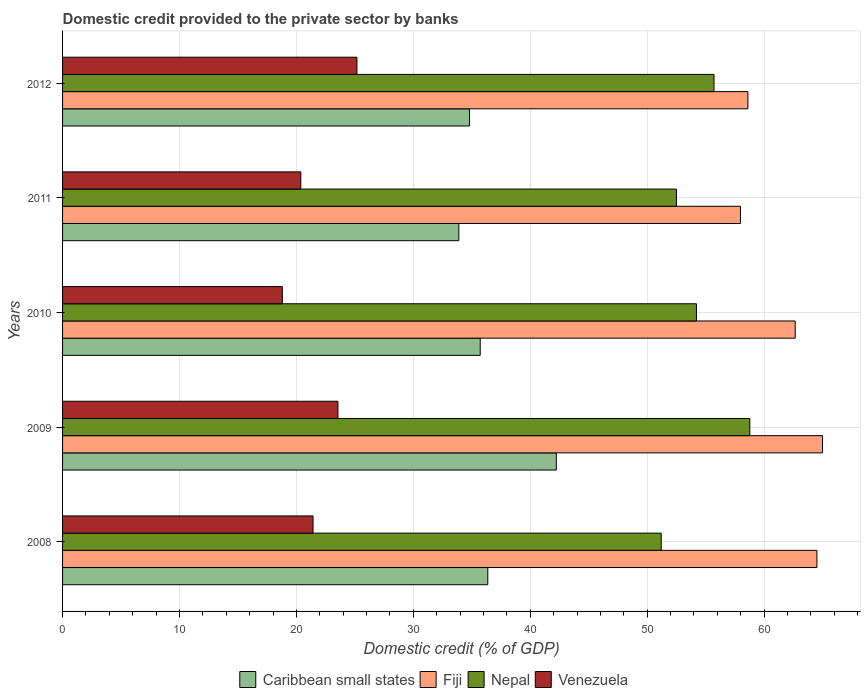How many different coloured bars are there?
Provide a succinct answer. 4. Are the number of bars per tick equal to the number of legend labels?
Your response must be concise. Yes. Are the number of bars on each tick of the Y-axis equal?
Give a very brief answer. Yes. How many bars are there on the 2nd tick from the top?
Offer a terse response. 4. How many bars are there on the 1st tick from the bottom?
Provide a short and direct response. 4. What is the domestic credit provided to the private sector by banks in Nepal in 2011?
Keep it short and to the point. 52.5. Across all years, what is the maximum domestic credit provided to the private sector by banks in Nepal?
Your response must be concise. 58.77. Across all years, what is the minimum domestic credit provided to the private sector by banks in Venezuela?
Keep it short and to the point. 18.8. In which year was the domestic credit provided to the private sector by banks in Nepal maximum?
Your answer should be compact. 2009. In which year was the domestic credit provided to the private sector by banks in Venezuela minimum?
Offer a very short reply. 2010. What is the total domestic credit provided to the private sector by banks in Venezuela in the graph?
Offer a terse response. 109.32. What is the difference between the domestic credit provided to the private sector by banks in Venezuela in 2009 and that in 2010?
Keep it short and to the point. 4.75. What is the difference between the domestic credit provided to the private sector by banks in Caribbean small states in 2008 and the domestic credit provided to the private sector by banks in Venezuela in 2012?
Keep it short and to the point. 11.19. What is the average domestic credit provided to the private sector by banks in Nepal per year?
Give a very brief answer. 54.48. In the year 2011, what is the difference between the domestic credit provided to the private sector by banks in Fiji and domestic credit provided to the private sector by banks in Venezuela?
Ensure brevity in your answer.  37.6. What is the ratio of the domestic credit provided to the private sector by banks in Fiji in 2010 to that in 2012?
Provide a short and direct response. 1.07. Is the domestic credit provided to the private sector by banks in Venezuela in 2011 less than that in 2012?
Your response must be concise. Yes. Is the difference between the domestic credit provided to the private sector by banks in Fiji in 2009 and 2010 greater than the difference between the domestic credit provided to the private sector by banks in Venezuela in 2009 and 2010?
Offer a terse response. No. What is the difference between the highest and the second highest domestic credit provided to the private sector by banks in Nepal?
Keep it short and to the point. 3.06. What is the difference between the highest and the lowest domestic credit provided to the private sector by banks in Nepal?
Offer a very short reply. 7.58. Is the sum of the domestic credit provided to the private sector by banks in Venezuela in 2008 and 2009 greater than the maximum domestic credit provided to the private sector by banks in Caribbean small states across all years?
Your response must be concise. Yes. What does the 4th bar from the top in 2012 represents?
Your response must be concise. Caribbean small states. What does the 4th bar from the bottom in 2011 represents?
Provide a succinct answer. Venezuela. How many bars are there?
Provide a succinct answer. 20. Are all the bars in the graph horizontal?
Ensure brevity in your answer.  Yes. How many years are there in the graph?
Keep it short and to the point. 5. Does the graph contain grids?
Provide a short and direct response. Yes. Where does the legend appear in the graph?
Your answer should be very brief. Bottom center. What is the title of the graph?
Give a very brief answer. Domestic credit provided to the private sector by banks. What is the label or title of the X-axis?
Provide a short and direct response. Domestic credit (% of GDP). What is the label or title of the Y-axis?
Give a very brief answer. Years. What is the Domestic credit (% of GDP) in Caribbean small states in 2008?
Make the answer very short. 36.37. What is the Domestic credit (% of GDP) of Fiji in 2008?
Offer a terse response. 64.51. What is the Domestic credit (% of GDP) in Nepal in 2008?
Your answer should be compact. 51.2. What is the Domestic credit (% of GDP) of Venezuela in 2008?
Your response must be concise. 21.42. What is the Domestic credit (% of GDP) in Caribbean small states in 2009?
Keep it short and to the point. 42.23. What is the Domestic credit (% of GDP) in Fiji in 2009?
Your answer should be very brief. 64.99. What is the Domestic credit (% of GDP) of Nepal in 2009?
Your response must be concise. 58.77. What is the Domestic credit (% of GDP) in Venezuela in 2009?
Provide a short and direct response. 23.55. What is the Domestic credit (% of GDP) in Caribbean small states in 2010?
Give a very brief answer. 35.72. What is the Domestic credit (% of GDP) in Fiji in 2010?
Make the answer very short. 62.66. What is the Domestic credit (% of GDP) of Nepal in 2010?
Provide a short and direct response. 54.21. What is the Domestic credit (% of GDP) in Venezuela in 2010?
Your answer should be very brief. 18.8. What is the Domestic credit (% of GDP) of Caribbean small states in 2011?
Your answer should be compact. 33.89. What is the Domestic credit (% of GDP) in Fiji in 2011?
Your answer should be very brief. 57.97. What is the Domestic credit (% of GDP) in Nepal in 2011?
Make the answer very short. 52.5. What is the Domestic credit (% of GDP) in Venezuela in 2011?
Provide a short and direct response. 20.37. What is the Domestic credit (% of GDP) of Caribbean small states in 2012?
Offer a very short reply. 34.81. What is the Domestic credit (% of GDP) of Fiji in 2012?
Your answer should be compact. 58.61. What is the Domestic credit (% of GDP) in Nepal in 2012?
Give a very brief answer. 55.71. What is the Domestic credit (% of GDP) of Venezuela in 2012?
Make the answer very short. 25.18. Across all years, what is the maximum Domestic credit (% of GDP) of Caribbean small states?
Offer a very short reply. 42.23. Across all years, what is the maximum Domestic credit (% of GDP) in Fiji?
Give a very brief answer. 64.99. Across all years, what is the maximum Domestic credit (% of GDP) in Nepal?
Offer a terse response. 58.77. Across all years, what is the maximum Domestic credit (% of GDP) in Venezuela?
Keep it short and to the point. 25.18. Across all years, what is the minimum Domestic credit (% of GDP) of Caribbean small states?
Offer a terse response. 33.89. Across all years, what is the minimum Domestic credit (% of GDP) in Fiji?
Provide a succinct answer. 57.97. Across all years, what is the minimum Domestic credit (% of GDP) of Nepal?
Provide a short and direct response. 51.2. Across all years, what is the minimum Domestic credit (% of GDP) of Venezuela?
Your answer should be very brief. 18.8. What is the total Domestic credit (% of GDP) of Caribbean small states in the graph?
Provide a short and direct response. 183.01. What is the total Domestic credit (% of GDP) in Fiji in the graph?
Your response must be concise. 308.75. What is the total Domestic credit (% of GDP) of Nepal in the graph?
Keep it short and to the point. 272.4. What is the total Domestic credit (% of GDP) of Venezuela in the graph?
Provide a short and direct response. 109.32. What is the difference between the Domestic credit (% of GDP) of Caribbean small states in 2008 and that in 2009?
Provide a short and direct response. -5.86. What is the difference between the Domestic credit (% of GDP) of Fiji in 2008 and that in 2009?
Your answer should be very brief. -0.48. What is the difference between the Domestic credit (% of GDP) in Nepal in 2008 and that in 2009?
Provide a short and direct response. -7.58. What is the difference between the Domestic credit (% of GDP) of Venezuela in 2008 and that in 2009?
Provide a short and direct response. -2.13. What is the difference between the Domestic credit (% of GDP) of Caribbean small states in 2008 and that in 2010?
Your answer should be compact. 0.65. What is the difference between the Domestic credit (% of GDP) in Fiji in 2008 and that in 2010?
Provide a short and direct response. 1.86. What is the difference between the Domestic credit (% of GDP) in Nepal in 2008 and that in 2010?
Offer a terse response. -3.01. What is the difference between the Domestic credit (% of GDP) in Venezuela in 2008 and that in 2010?
Give a very brief answer. 2.62. What is the difference between the Domestic credit (% of GDP) of Caribbean small states in 2008 and that in 2011?
Your response must be concise. 2.48. What is the difference between the Domestic credit (% of GDP) of Fiji in 2008 and that in 2011?
Provide a succinct answer. 6.54. What is the difference between the Domestic credit (% of GDP) in Nepal in 2008 and that in 2011?
Provide a short and direct response. -1.3. What is the difference between the Domestic credit (% of GDP) of Venezuela in 2008 and that in 2011?
Your answer should be compact. 1.05. What is the difference between the Domestic credit (% of GDP) in Caribbean small states in 2008 and that in 2012?
Offer a terse response. 1.56. What is the difference between the Domestic credit (% of GDP) in Fiji in 2008 and that in 2012?
Ensure brevity in your answer.  5.9. What is the difference between the Domestic credit (% of GDP) in Nepal in 2008 and that in 2012?
Ensure brevity in your answer.  -4.52. What is the difference between the Domestic credit (% of GDP) in Venezuela in 2008 and that in 2012?
Your answer should be very brief. -3.75. What is the difference between the Domestic credit (% of GDP) in Caribbean small states in 2009 and that in 2010?
Your answer should be very brief. 6.51. What is the difference between the Domestic credit (% of GDP) of Fiji in 2009 and that in 2010?
Provide a succinct answer. 2.33. What is the difference between the Domestic credit (% of GDP) of Nepal in 2009 and that in 2010?
Offer a very short reply. 4.56. What is the difference between the Domestic credit (% of GDP) of Venezuela in 2009 and that in 2010?
Keep it short and to the point. 4.75. What is the difference between the Domestic credit (% of GDP) in Caribbean small states in 2009 and that in 2011?
Your response must be concise. 8.34. What is the difference between the Domestic credit (% of GDP) in Fiji in 2009 and that in 2011?
Give a very brief answer. 7.02. What is the difference between the Domestic credit (% of GDP) of Nepal in 2009 and that in 2011?
Your response must be concise. 6.28. What is the difference between the Domestic credit (% of GDP) of Venezuela in 2009 and that in 2011?
Your answer should be compact. 3.18. What is the difference between the Domestic credit (% of GDP) of Caribbean small states in 2009 and that in 2012?
Offer a very short reply. 7.42. What is the difference between the Domestic credit (% of GDP) of Fiji in 2009 and that in 2012?
Offer a terse response. 6.38. What is the difference between the Domestic credit (% of GDP) of Nepal in 2009 and that in 2012?
Give a very brief answer. 3.06. What is the difference between the Domestic credit (% of GDP) of Venezuela in 2009 and that in 2012?
Your response must be concise. -1.62. What is the difference between the Domestic credit (% of GDP) in Caribbean small states in 2010 and that in 2011?
Your answer should be very brief. 1.83. What is the difference between the Domestic credit (% of GDP) in Fiji in 2010 and that in 2011?
Your response must be concise. 4.68. What is the difference between the Domestic credit (% of GDP) of Nepal in 2010 and that in 2011?
Provide a succinct answer. 1.71. What is the difference between the Domestic credit (% of GDP) of Venezuela in 2010 and that in 2011?
Ensure brevity in your answer.  -1.58. What is the difference between the Domestic credit (% of GDP) of Caribbean small states in 2010 and that in 2012?
Provide a succinct answer. 0.91. What is the difference between the Domestic credit (% of GDP) in Fiji in 2010 and that in 2012?
Give a very brief answer. 4.05. What is the difference between the Domestic credit (% of GDP) in Nepal in 2010 and that in 2012?
Ensure brevity in your answer.  -1.5. What is the difference between the Domestic credit (% of GDP) in Venezuela in 2010 and that in 2012?
Keep it short and to the point. -6.38. What is the difference between the Domestic credit (% of GDP) in Caribbean small states in 2011 and that in 2012?
Your answer should be very brief. -0.92. What is the difference between the Domestic credit (% of GDP) in Fiji in 2011 and that in 2012?
Keep it short and to the point. -0.64. What is the difference between the Domestic credit (% of GDP) of Nepal in 2011 and that in 2012?
Offer a terse response. -3.21. What is the difference between the Domestic credit (% of GDP) in Venezuela in 2011 and that in 2012?
Provide a succinct answer. -4.8. What is the difference between the Domestic credit (% of GDP) in Caribbean small states in 2008 and the Domestic credit (% of GDP) in Fiji in 2009?
Ensure brevity in your answer.  -28.62. What is the difference between the Domestic credit (% of GDP) in Caribbean small states in 2008 and the Domestic credit (% of GDP) in Nepal in 2009?
Ensure brevity in your answer.  -22.41. What is the difference between the Domestic credit (% of GDP) of Caribbean small states in 2008 and the Domestic credit (% of GDP) of Venezuela in 2009?
Ensure brevity in your answer.  12.82. What is the difference between the Domestic credit (% of GDP) of Fiji in 2008 and the Domestic credit (% of GDP) of Nepal in 2009?
Your answer should be very brief. 5.74. What is the difference between the Domestic credit (% of GDP) of Fiji in 2008 and the Domestic credit (% of GDP) of Venezuela in 2009?
Offer a very short reply. 40.96. What is the difference between the Domestic credit (% of GDP) in Nepal in 2008 and the Domestic credit (% of GDP) in Venezuela in 2009?
Make the answer very short. 27.65. What is the difference between the Domestic credit (% of GDP) in Caribbean small states in 2008 and the Domestic credit (% of GDP) in Fiji in 2010?
Ensure brevity in your answer.  -26.29. What is the difference between the Domestic credit (% of GDP) of Caribbean small states in 2008 and the Domestic credit (% of GDP) of Nepal in 2010?
Keep it short and to the point. -17.85. What is the difference between the Domestic credit (% of GDP) of Caribbean small states in 2008 and the Domestic credit (% of GDP) of Venezuela in 2010?
Keep it short and to the point. 17.57. What is the difference between the Domestic credit (% of GDP) of Fiji in 2008 and the Domestic credit (% of GDP) of Nepal in 2010?
Give a very brief answer. 10.3. What is the difference between the Domestic credit (% of GDP) in Fiji in 2008 and the Domestic credit (% of GDP) in Venezuela in 2010?
Keep it short and to the point. 45.72. What is the difference between the Domestic credit (% of GDP) in Nepal in 2008 and the Domestic credit (% of GDP) in Venezuela in 2010?
Your answer should be very brief. 32.4. What is the difference between the Domestic credit (% of GDP) in Caribbean small states in 2008 and the Domestic credit (% of GDP) in Fiji in 2011?
Your answer should be compact. -21.61. What is the difference between the Domestic credit (% of GDP) of Caribbean small states in 2008 and the Domestic credit (% of GDP) of Nepal in 2011?
Offer a terse response. -16.13. What is the difference between the Domestic credit (% of GDP) of Caribbean small states in 2008 and the Domestic credit (% of GDP) of Venezuela in 2011?
Your answer should be compact. 15.99. What is the difference between the Domestic credit (% of GDP) in Fiji in 2008 and the Domestic credit (% of GDP) in Nepal in 2011?
Provide a short and direct response. 12.01. What is the difference between the Domestic credit (% of GDP) of Fiji in 2008 and the Domestic credit (% of GDP) of Venezuela in 2011?
Your response must be concise. 44.14. What is the difference between the Domestic credit (% of GDP) of Nepal in 2008 and the Domestic credit (% of GDP) of Venezuela in 2011?
Keep it short and to the point. 30.82. What is the difference between the Domestic credit (% of GDP) in Caribbean small states in 2008 and the Domestic credit (% of GDP) in Fiji in 2012?
Provide a short and direct response. -22.24. What is the difference between the Domestic credit (% of GDP) of Caribbean small states in 2008 and the Domestic credit (% of GDP) of Nepal in 2012?
Offer a terse response. -19.35. What is the difference between the Domestic credit (% of GDP) in Caribbean small states in 2008 and the Domestic credit (% of GDP) in Venezuela in 2012?
Provide a succinct answer. 11.19. What is the difference between the Domestic credit (% of GDP) in Fiji in 2008 and the Domestic credit (% of GDP) in Nepal in 2012?
Your answer should be compact. 8.8. What is the difference between the Domestic credit (% of GDP) in Fiji in 2008 and the Domestic credit (% of GDP) in Venezuela in 2012?
Give a very brief answer. 39.34. What is the difference between the Domestic credit (% of GDP) of Nepal in 2008 and the Domestic credit (% of GDP) of Venezuela in 2012?
Offer a very short reply. 26.02. What is the difference between the Domestic credit (% of GDP) in Caribbean small states in 2009 and the Domestic credit (% of GDP) in Fiji in 2010?
Offer a terse response. -20.43. What is the difference between the Domestic credit (% of GDP) in Caribbean small states in 2009 and the Domestic credit (% of GDP) in Nepal in 2010?
Your answer should be very brief. -11.99. What is the difference between the Domestic credit (% of GDP) of Caribbean small states in 2009 and the Domestic credit (% of GDP) of Venezuela in 2010?
Provide a short and direct response. 23.43. What is the difference between the Domestic credit (% of GDP) in Fiji in 2009 and the Domestic credit (% of GDP) in Nepal in 2010?
Give a very brief answer. 10.78. What is the difference between the Domestic credit (% of GDP) of Fiji in 2009 and the Domestic credit (% of GDP) of Venezuela in 2010?
Keep it short and to the point. 46.19. What is the difference between the Domestic credit (% of GDP) in Nepal in 2009 and the Domestic credit (% of GDP) in Venezuela in 2010?
Ensure brevity in your answer.  39.98. What is the difference between the Domestic credit (% of GDP) in Caribbean small states in 2009 and the Domestic credit (% of GDP) in Fiji in 2011?
Your answer should be compact. -15.75. What is the difference between the Domestic credit (% of GDP) of Caribbean small states in 2009 and the Domestic credit (% of GDP) of Nepal in 2011?
Give a very brief answer. -10.27. What is the difference between the Domestic credit (% of GDP) of Caribbean small states in 2009 and the Domestic credit (% of GDP) of Venezuela in 2011?
Provide a short and direct response. 21.85. What is the difference between the Domestic credit (% of GDP) of Fiji in 2009 and the Domestic credit (% of GDP) of Nepal in 2011?
Your answer should be compact. 12.49. What is the difference between the Domestic credit (% of GDP) of Fiji in 2009 and the Domestic credit (% of GDP) of Venezuela in 2011?
Offer a terse response. 44.62. What is the difference between the Domestic credit (% of GDP) in Nepal in 2009 and the Domestic credit (% of GDP) in Venezuela in 2011?
Your response must be concise. 38.4. What is the difference between the Domestic credit (% of GDP) of Caribbean small states in 2009 and the Domestic credit (% of GDP) of Fiji in 2012?
Make the answer very short. -16.38. What is the difference between the Domestic credit (% of GDP) of Caribbean small states in 2009 and the Domestic credit (% of GDP) of Nepal in 2012?
Your response must be concise. -13.49. What is the difference between the Domestic credit (% of GDP) in Caribbean small states in 2009 and the Domestic credit (% of GDP) in Venezuela in 2012?
Your response must be concise. 17.05. What is the difference between the Domestic credit (% of GDP) of Fiji in 2009 and the Domestic credit (% of GDP) of Nepal in 2012?
Make the answer very short. 9.28. What is the difference between the Domestic credit (% of GDP) in Fiji in 2009 and the Domestic credit (% of GDP) in Venezuela in 2012?
Offer a terse response. 39.82. What is the difference between the Domestic credit (% of GDP) in Nepal in 2009 and the Domestic credit (% of GDP) in Venezuela in 2012?
Provide a short and direct response. 33.6. What is the difference between the Domestic credit (% of GDP) in Caribbean small states in 2010 and the Domestic credit (% of GDP) in Fiji in 2011?
Your answer should be very brief. -22.25. What is the difference between the Domestic credit (% of GDP) of Caribbean small states in 2010 and the Domestic credit (% of GDP) of Nepal in 2011?
Keep it short and to the point. -16.78. What is the difference between the Domestic credit (% of GDP) in Caribbean small states in 2010 and the Domestic credit (% of GDP) in Venezuela in 2011?
Provide a succinct answer. 15.35. What is the difference between the Domestic credit (% of GDP) in Fiji in 2010 and the Domestic credit (% of GDP) in Nepal in 2011?
Your response must be concise. 10.16. What is the difference between the Domestic credit (% of GDP) in Fiji in 2010 and the Domestic credit (% of GDP) in Venezuela in 2011?
Provide a short and direct response. 42.28. What is the difference between the Domestic credit (% of GDP) in Nepal in 2010 and the Domestic credit (% of GDP) in Venezuela in 2011?
Give a very brief answer. 33.84. What is the difference between the Domestic credit (% of GDP) in Caribbean small states in 2010 and the Domestic credit (% of GDP) in Fiji in 2012?
Keep it short and to the point. -22.89. What is the difference between the Domestic credit (% of GDP) of Caribbean small states in 2010 and the Domestic credit (% of GDP) of Nepal in 2012?
Provide a short and direct response. -19.99. What is the difference between the Domestic credit (% of GDP) of Caribbean small states in 2010 and the Domestic credit (% of GDP) of Venezuela in 2012?
Offer a very short reply. 10.54. What is the difference between the Domestic credit (% of GDP) in Fiji in 2010 and the Domestic credit (% of GDP) in Nepal in 2012?
Your answer should be very brief. 6.95. What is the difference between the Domestic credit (% of GDP) in Fiji in 2010 and the Domestic credit (% of GDP) in Venezuela in 2012?
Your response must be concise. 37.48. What is the difference between the Domestic credit (% of GDP) of Nepal in 2010 and the Domestic credit (% of GDP) of Venezuela in 2012?
Provide a succinct answer. 29.04. What is the difference between the Domestic credit (% of GDP) of Caribbean small states in 2011 and the Domestic credit (% of GDP) of Fiji in 2012?
Ensure brevity in your answer.  -24.72. What is the difference between the Domestic credit (% of GDP) in Caribbean small states in 2011 and the Domestic credit (% of GDP) in Nepal in 2012?
Keep it short and to the point. -21.82. What is the difference between the Domestic credit (% of GDP) of Caribbean small states in 2011 and the Domestic credit (% of GDP) of Venezuela in 2012?
Offer a very short reply. 8.71. What is the difference between the Domestic credit (% of GDP) of Fiji in 2011 and the Domestic credit (% of GDP) of Nepal in 2012?
Your answer should be compact. 2.26. What is the difference between the Domestic credit (% of GDP) of Fiji in 2011 and the Domestic credit (% of GDP) of Venezuela in 2012?
Provide a short and direct response. 32.8. What is the difference between the Domestic credit (% of GDP) in Nepal in 2011 and the Domestic credit (% of GDP) in Venezuela in 2012?
Offer a terse response. 27.32. What is the average Domestic credit (% of GDP) of Caribbean small states per year?
Your answer should be compact. 36.6. What is the average Domestic credit (% of GDP) of Fiji per year?
Offer a terse response. 61.75. What is the average Domestic credit (% of GDP) of Nepal per year?
Your response must be concise. 54.48. What is the average Domestic credit (% of GDP) in Venezuela per year?
Your answer should be compact. 21.86. In the year 2008, what is the difference between the Domestic credit (% of GDP) in Caribbean small states and Domestic credit (% of GDP) in Fiji?
Provide a short and direct response. -28.15. In the year 2008, what is the difference between the Domestic credit (% of GDP) of Caribbean small states and Domestic credit (% of GDP) of Nepal?
Your answer should be compact. -14.83. In the year 2008, what is the difference between the Domestic credit (% of GDP) in Caribbean small states and Domestic credit (% of GDP) in Venezuela?
Your answer should be very brief. 14.95. In the year 2008, what is the difference between the Domestic credit (% of GDP) in Fiji and Domestic credit (% of GDP) in Nepal?
Offer a very short reply. 13.32. In the year 2008, what is the difference between the Domestic credit (% of GDP) in Fiji and Domestic credit (% of GDP) in Venezuela?
Your response must be concise. 43.09. In the year 2008, what is the difference between the Domestic credit (% of GDP) in Nepal and Domestic credit (% of GDP) in Venezuela?
Keep it short and to the point. 29.78. In the year 2009, what is the difference between the Domestic credit (% of GDP) of Caribbean small states and Domestic credit (% of GDP) of Fiji?
Offer a very short reply. -22.76. In the year 2009, what is the difference between the Domestic credit (% of GDP) of Caribbean small states and Domestic credit (% of GDP) of Nepal?
Give a very brief answer. -16.55. In the year 2009, what is the difference between the Domestic credit (% of GDP) in Caribbean small states and Domestic credit (% of GDP) in Venezuela?
Provide a short and direct response. 18.68. In the year 2009, what is the difference between the Domestic credit (% of GDP) in Fiji and Domestic credit (% of GDP) in Nepal?
Provide a succinct answer. 6.22. In the year 2009, what is the difference between the Domestic credit (% of GDP) in Fiji and Domestic credit (% of GDP) in Venezuela?
Keep it short and to the point. 41.44. In the year 2009, what is the difference between the Domestic credit (% of GDP) in Nepal and Domestic credit (% of GDP) in Venezuela?
Your answer should be compact. 35.22. In the year 2010, what is the difference between the Domestic credit (% of GDP) of Caribbean small states and Domestic credit (% of GDP) of Fiji?
Offer a terse response. -26.94. In the year 2010, what is the difference between the Domestic credit (% of GDP) in Caribbean small states and Domestic credit (% of GDP) in Nepal?
Offer a very short reply. -18.49. In the year 2010, what is the difference between the Domestic credit (% of GDP) in Caribbean small states and Domestic credit (% of GDP) in Venezuela?
Your answer should be compact. 16.92. In the year 2010, what is the difference between the Domestic credit (% of GDP) in Fiji and Domestic credit (% of GDP) in Nepal?
Provide a succinct answer. 8.45. In the year 2010, what is the difference between the Domestic credit (% of GDP) of Fiji and Domestic credit (% of GDP) of Venezuela?
Make the answer very short. 43.86. In the year 2010, what is the difference between the Domestic credit (% of GDP) of Nepal and Domestic credit (% of GDP) of Venezuela?
Offer a terse response. 35.42. In the year 2011, what is the difference between the Domestic credit (% of GDP) of Caribbean small states and Domestic credit (% of GDP) of Fiji?
Offer a very short reply. -24.08. In the year 2011, what is the difference between the Domestic credit (% of GDP) of Caribbean small states and Domestic credit (% of GDP) of Nepal?
Ensure brevity in your answer.  -18.61. In the year 2011, what is the difference between the Domestic credit (% of GDP) in Caribbean small states and Domestic credit (% of GDP) in Venezuela?
Give a very brief answer. 13.52. In the year 2011, what is the difference between the Domestic credit (% of GDP) of Fiji and Domestic credit (% of GDP) of Nepal?
Offer a terse response. 5.47. In the year 2011, what is the difference between the Domestic credit (% of GDP) of Fiji and Domestic credit (% of GDP) of Venezuela?
Offer a terse response. 37.6. In the year 2011, what is the difference between the Domestic credit (% of GDP) in Nepal and Domestic credit (% of GDP) in Venezuela?
Provide a succinct answer. 32.13. In the year 2012, what is the difference between the Domestic credit (% of GDP) in Caribbean small states and Domestic credit (% of GDP) in Fiji?
Ensure brevity in your answer.  -23.8. In the year 2012, what is the difference between the Domestic credit (% of GDP) in Caribbean small states and Domestic credit (% of GDP) in Nepal?
Your answer should be compact. -20.91. In the year 2012, what is the difference between the Domestic credit (% of GDP) in Caribbean small states and Domestic credit (% of GDP) in Venezuela?
Offer a terse response. 9.63. In the year 2012, what is the difference between the Domestic credit (% of GDP) of Fiji and Domestic credit (% of GDP) of Nepal?
Your answer should be very brief. 2.9. In the year 2012, what is the difference between the Domestic credit (% of GDP) of Fiji and Domestic credit (% of GDP) of Venezuela?
Offer a terse response. 33.44. In the year 2012, what is the difference between the Domestic credit (% of GDP) in Nepal and Domestic credit (% of GDP) in Venezuela?
Your response must be concise. 30.54. What is the ratio of the Domestic credit (% of GDP) in Caribbean small states in 2008 to that in 2009?
Your answer should be very brief. 0.86. What is the ratio of the Domestic credit (% of GDP) in Nepal in 2008 to that in 2009?
Offer a terse response. 0.87. What is the ratio of the Domestic credit (% of GDP) in Venezuela in 2008 to that in 2009?
Your answer should be compact. 0.91. What is the ratio of the Domestic credit (% of GDP) of Caribbean small states in 2008 to that in 2010?
Ensure brevity in your answer.  1.02. What is the ratio of the Domestic credit (% of GDP) in Fiji in 2008 to that in 2010?
Ensure brevity in your answer.  1.03. What is the ratio of the Domestic credit (% of GDP) in Nepal in 2008 to that in 2010?
Offer a terse response. 0.94. What is the ratio of the Domestic credit (% of GDP) of Venezuela in 2008 to that in 2010?
Keep it short and to the point. 1.14. What is the ratio of the Domestic credit (% of GDP) of Caribbean small states in 2008 to that in 2011?
Your answer should be compact. 1.07. What is the ratio of the Domestic credit (% of GDP) in Fiji in 2008 to that in 2011?
Give a very brief answer. 1.11. What is the ratio of the Domestic credit (% of GDP) of Nepal in 2008 to that in 2011?
Your answer should be very brief. 0.98. What is the ratio of the Domestic credit (% of GDP) in Venezuela in 2008 to that in 2011?
Provide a succinct answer. 1.05. What is the ratio of the Domestic credit (% of GDP) in Caribbean small states in 2008 to that in 2012?
Make the answer very short. 1.04. What is the ratio of the Domestic credit (% of GDP) of Fiji in 2008 to that in 2012?
Your answer should be very brief. 1.1. What is the ratio of the Domestic credit (% of GDP) of Nepal in 2008 to that in 2012?
Your response must be concise. 0.92. What is the ratio of the Domestic credit (% of GDP) in Venezuela in 2008 to that in 2012?
Ensure brevity in your answer.  0.85. What is the ratio of the Domestic credit (% of GDP) of Caribbean small states in 2009 to that in 2010?
Your answer should be very brief. 1.18. What is the ratio of the Domestic credit (% of GDP) of Fiji in 2009 to that in 2010?
Make the answer very short. 1.04. What is the ratio of the Domestic credit (% of GDP) of Nepal in 2009 to that in 2010?
Your answer should be very brief. 1.08. What is the ratio of the Domestic credit (% of GDP) of Venezuela in 2009 to that in 2010?
Provide a succinct answer. 1.25. What is the ratio of the Domestic credit (% of GDP) of Caribbean small states in 2009 to that in 2011?
Give a very brief answer. 1.25. What is the ratio of the Domestic credit (% of GDP) in Fiji in 2009 to that in 2011?
Your response must be concise. 1.12. What is the ratio of the Domestic credit (% of GDP) in Nepal in 2009 to that in 2011?
Keep it short and to the point. 1.12. What is the ratio of the Domestic credit (% of GDP) in Venezuela in 2009 to that in 2011?
Give a very brief answer. 1.16. What is the ratio of the Domestic credit (% of GDP) of Caribbean small states in 2009 to that in 2012?
Ensure brevity in your answer.  1.21. What is the ratio of the Domestic credit (% of GDP) of Fiji in 2009 to that in 2012?
Your answer should be very brief. 1.11. What is the ratio of the Domestic credit (% of GDP) in Nepal in 2009 to that in 2012?
Your response must be concise. 1.05. What is the ratio of the Domestic credit (% of GDP) in Venezuela in 2009 to that in 2012?
Provide a succinct answer. 0.94. What is the ratio of the Domestic credit (% of GDP) of Caribbean small states in 2010 to that in 2011?
Offer a terse response. 1.05. What is the ratio of the Domestic credit (% of GDP) in Fiji in 2010 to that in 2011?
Your answer should be compact. 1.08. What is the ratio of the Domestic credit (% of GDP) in Nepal in 2010 to that in 2011?
Ensure brevity in your answer.  1.03. What is the ratio of the Domestic credit (% of GDP) in Venezuela in 2010 to that in 2011?
Provide a short and direct response. 0.92. What is the ratio of the Domestic credit (% of GDP) of Caribbean small states in 2010 to that in 2012?
Offer a terse response. 1.03. What is the ratio of the Domestic credit (% of GDP) of Fiji in 2010 to that in 2012?
Your answer should be very brief. 1.07. What is the ratio of the Domestic credit (% of GDP) in Nepal in 2010 to that in 2012?
Offer a terse response. 0.97. What is the ratio of the Domestic credit (% of GDP) in Venezuela in 2010 to that in 2012?
Your response must be concise. 0.75. What is the ratio of the Domestic credit (% of GDP) of Caribbean small states in 2011 to that in 2012?
Offer a very short reply. 0.97. What is the ratio of the Domestic credit (% of GDP) in Fiji in 2011 to that in 2012?
Your response must be concise. 0.99. What is the ratio of the Domestic credit (% of GDP) of Nepal in 2011 to that in 2012?
Ensure brevity in your answer.  0.94. What is the ratio of the Domestic credit (% of GDP) in Venezuela in 2011 to that in 2012?
Ensure brevity in your answer.  0.81. What is the difference between the highest and the second highest Domestic credit (% of GDP) of Caribbean small states?
Provide a short and direct response. 5.86. What is the difference between the highest and the second highest Domestic credit (% of GDP) in Fiji?
Make the answer very short. 0.48. What is the difference between the highest and the second highest Domestic credit (% of GDP) of Nepal?
Make the answer very short. 3.06. What is the difference between the highest and the second highest Domestic credit (% of GDP) of Venezuela?
Offer a terse response. 1.62. What is the difference between the highest and the lowest Domestic credit (% of GDP) in Caribbean small states?
Your answer should be compact. 8.34. What is the difference between the highest and the lowest Domestic credit (% of GDP) in Fiji?
Your answer should be very brief. 7.02. What is the difference between the highest and the lowest Domestic credit (% of GDP) in Nepal?
Keep it short and to the point. 7.58. What is the difference between the highest and the lowest Domestic credit (% of GDP) in Venezuela?
Offer a terse response. 6.38. 